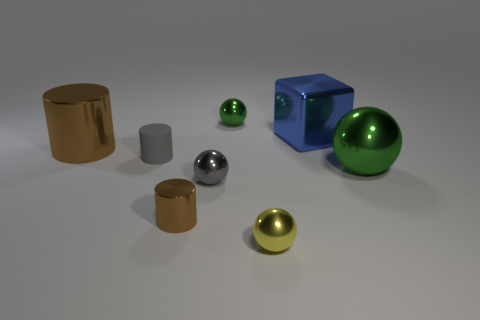Subtract all big brown shiny cylinders. How many cylinders are left? 2 Subtract all gray blocks. How many brown cylinders are left? 2 Subtract 2 spheres. How many spheres are left? 2 Add 1 matte objects. How many objects exist? 9 Subtract all yellow balls. How many balls are left? 3 Subtract all blocks. How many objects are left? 7 Subtract all green cylinders. Subtract all purple spheres. How many cylinders are left? 3 Subtract 0 cyan spheres. How many objects are left? 8 Subtract all blue cubes. Subtract all large blue shiny blocks. How many objects are left? 6 Add 7 small gray shiny spheres. How many small gray shiny spheres are left? 8 